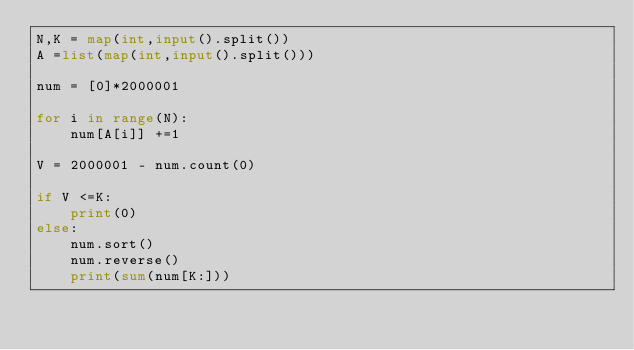Convert code to text. <code><loc_0><loc_0><loc_500><loc_500><_Python_>N,K = map(int,input().split())
A =list(map(int,input().split()))

num = [0]*2000001

for i in range(N):
    num[A[i]] +=1

V = 2000001 - num.count(0)

if V <=K:
    print(0)
else:
    num.sort()
    num.reverse()
    print(sum(num[K:]))</code> 